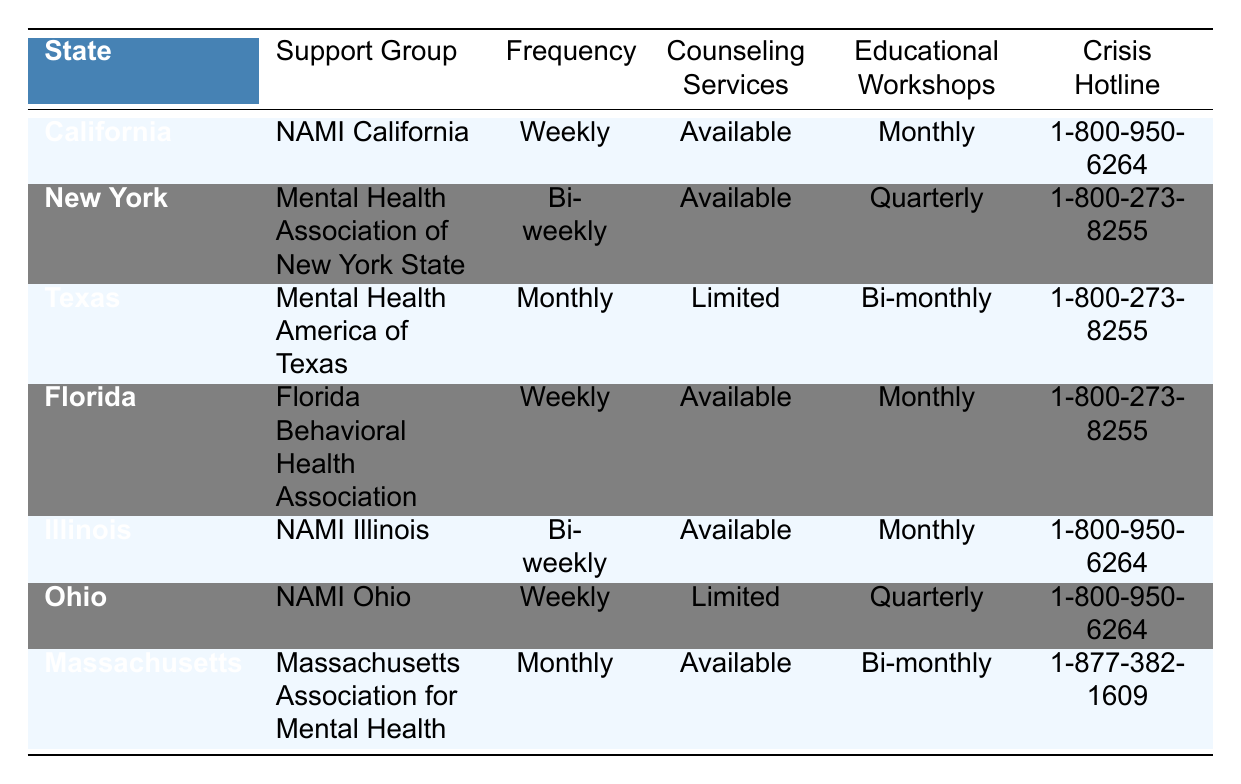What support group is available in Florida? From the table, the support group listed for Florida is the Florida Behavioral Health Association.
Answer: Florida Behavioral Health Association How often do support groups meet in California? The table indicates that support groups in California meet weekly.
Answer: Weekly Is there a crisis hotline available for all the states listed? Yes, every state in the table has a crisis hotline listed.
Answer: Yes Which state has limited counseling services? The table shows that Texas and Ohio are the states with limited counseling services.
Answer: Texas and Ohio What is the frequency of educational workshops in Massachusetts? According to the table, Massachusetts has educational workshops that occur bi-monthly.
Answer: Bi-monthly Which states offer monthly educational workshops? By examining the table, Massachusetts, California, and Florida offer monthly educational workshops.
Answer: Massachusetts, California, and Florida Is there a difference in counseling services between California and New York? California has available counseling services, while New York also has available services, so there’s no difference.
Answer: No difference Which state has the crisis hotline number 1-800-950-6264? The states with the crisis hotline number 1-800-950-6264 are California, Illinois, and Ohio.
Answer: California, Illinois, and Ohio How many states provide available counseling services? The table indicates that California, New York, Florida, Illinois, and Massachusetts have available counseling services, totaling five states.
Answer: Five states If someone wanted to attend support groups weekly, which states would they consider? The states with weekly support groups are California, Florida, and Ohio.
Answer: California, Florida, and Ohio 